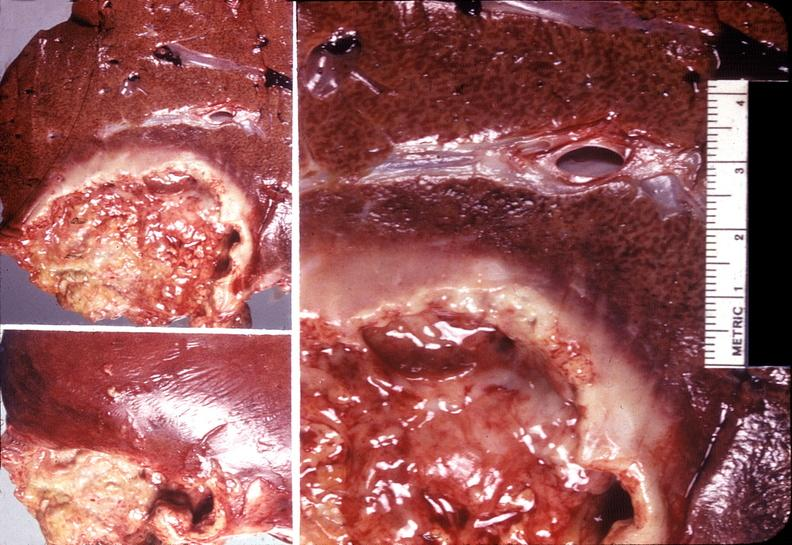does this image show liver, ameobic abscesses?
Answer the question using a single word or phrase. Yes 